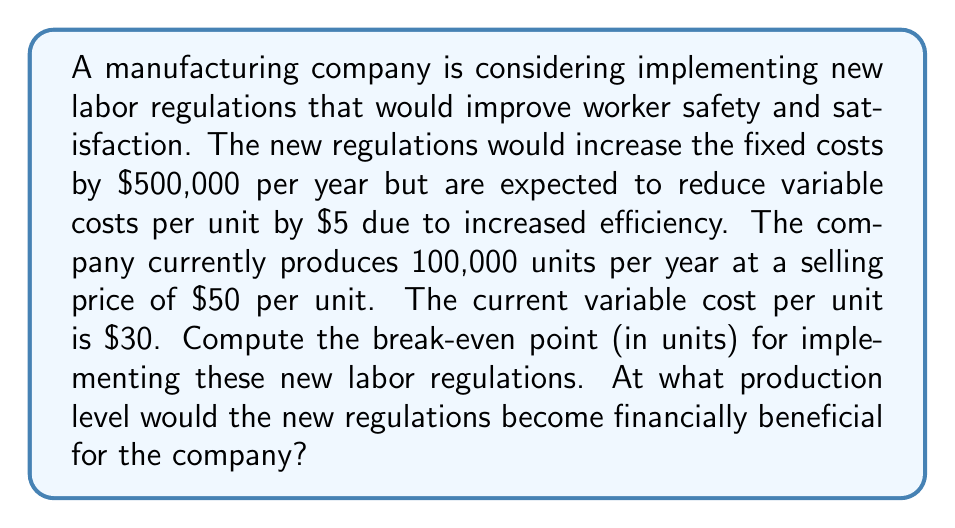Show me your answer to this math problem. To solve this problem, we need to find the break-even point where the total costs under the new regulations equal the total costs under the current system. Let's approach this step-by-step:

1. Define variables:
   $x$ = number of units produced
   $FC_{old}$ = current fixed costs
   $FC_{new}$ = new fixed costs
   $VC_{old}$ = current variable costs per unit
   $VC_{new}$ = new variable costs per unit

2. Set up the equation:
   Total costs should be equal at the break-even point:
   $$FC_{old} + VC_{old} \cdot x = FC_{new} + VC_{new} \cdot x$$

3. Insert known values:
   $FC_{new} = FC_{old} + 500,000$ (increased by $500,000)
   $VC_{new} = 30 - 5 = 25$ (reduced by $5)
   $$FC_{old} + 30x = (FC_{old} + 500,000) + 25x$$

4. Simplify and solve for $x$:
   $$FC_{old} + 30x = FC_{old} + 500,000 + 25x$$
   $$30x - 25x = 500,000$$
   $$5x = 500,000$$
   $$x = 100,000$$

5. Interpret the result:
   The break-even point is 100,000 units. At this production level, the costs under both systems are equal. For any production level above 100,000 units, the new regulations become financially beneficial.

6. Verify with current production:
   The company currently produces 100,000 units per year, which is exactly at the break-even point. This means that implementing the new regulations would have no immediate financial impact, but any increase in production would make the new regulations profitable.
Answer: The break-even point is 100,000 units. The new labor regulations become financially beneficial for the company at any production level above 100,000 units per year. 